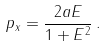Convert formula to latex. <formula><loc_0><loc_0><loc_500><loc_500>p _ { x } = \frac { 2 a E } { 1 + E ^ { 2 } } \, .</formula> 